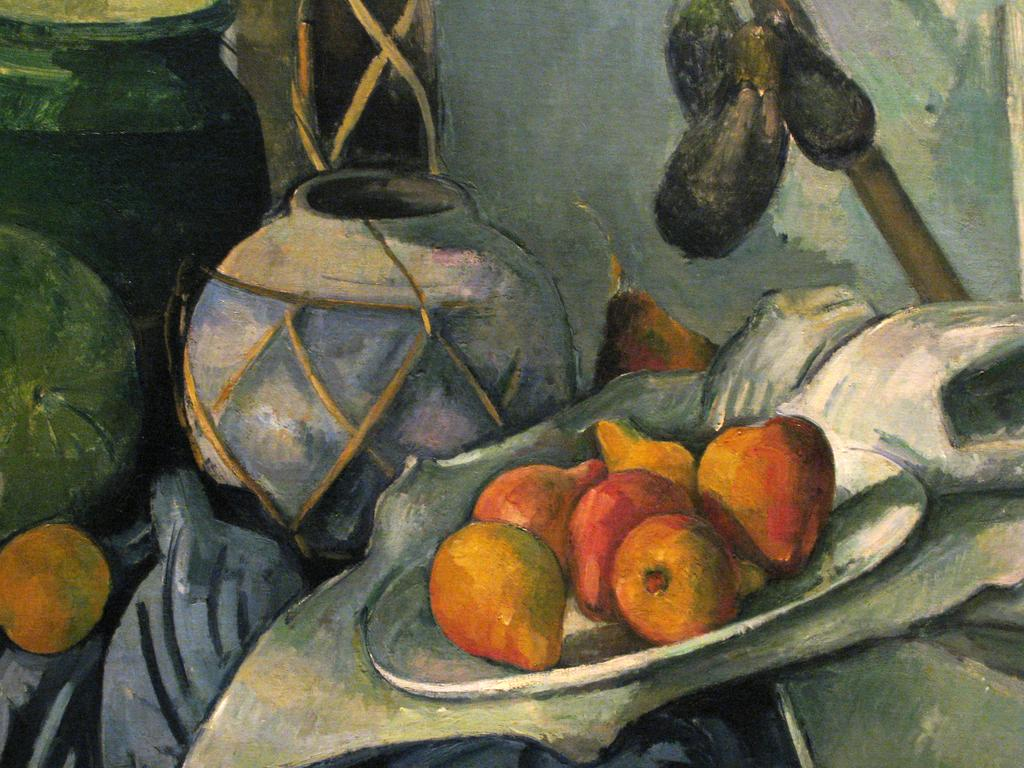What type of artwork is depicted in the image? The image contains a painting picture. What elements are included in the painting picture? The painting picture includes fruits, pots, plates, and other objects. How many beans are present in the painting picture? There is no mention of beans in the painting picture; it includes fruits, pots, plates, and other objects. What trick is being performed by the objects in the painting picture? There is no trick being performed by the objects in the painting picture; it is a still image of various objects. 